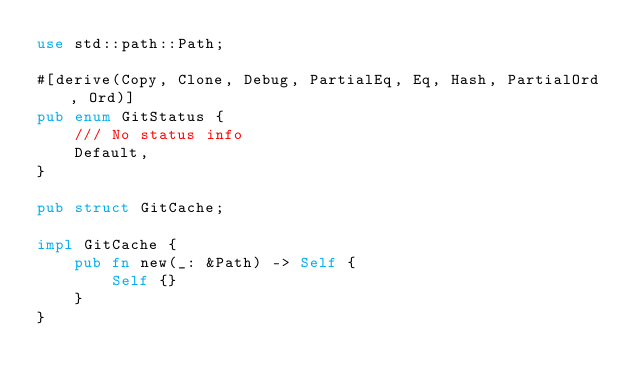<code> <loc_0><loc_0><loc_500><loc_500><_Rust_>use std::path::Path;

#[derive(Copy, Clone, Debug, PartialEq, Eq, Hash, PartialOrd, Ord)]
pub enum GitStatus {
    /// No status info
    Default,
}

pub struct GitCache;

impl GitCache {
    pub fn new(_: &Path) -> Self {
        Self {}
    }
}</code> 